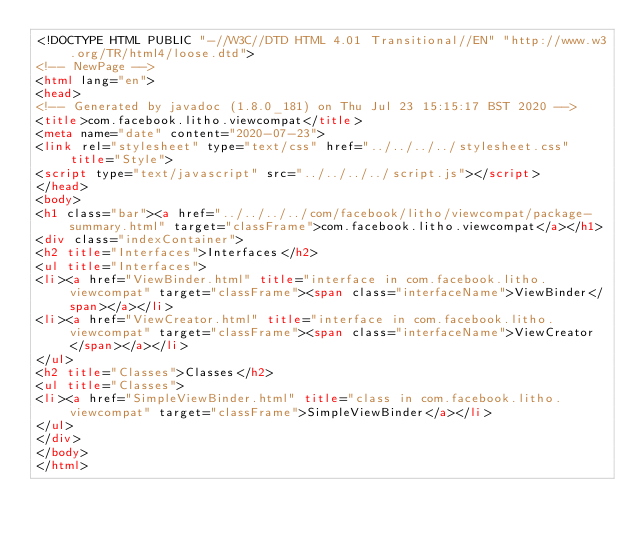<code> <loc_0><loc_0><loc_500><loc_500><_HTML_><!DOCTYPE HTML PUBLIC "-//W3C//DTD HTML 4.01 Transitional//EN" "http://www.w3.org/TR/html4/loose.dtd">
<!-- NewPage -->
<html lang="en">
<head>
<!-- Generated by javadoc (1.8.0_181) on Thu Jul 23 15:15:17 BST 2020 -->
<title>com.facebook.litho.viewcompat</title>
<meta name="date" content="2020-07-23">
<link rel="stylesheet" type="text/css" href="../../../../stylesheet.css" title="Style">
<script type="text/javascript" src="../../../../script.js"></script>
</head>
<body>
<h1 class="bar"><a href="../../../../com/facebook/litho/viewcompat/package-summary.html" target="classFrame">com.facebook.litho.viewcompat</a></h1>
<div class="indexContainer">
<h2 title="Interfaces">Interfaces</h2>
<ul title="Interfaces">
<li><a href="ViewBinder.html" title="interface in com.facebook.litho.viewcompat" target="classFrame"><span class="interfaceName">ViewBinder</span></a></li>
<li><a href="ViewCreator.html" title="interface in com.facebook.litho.viewcompat" target="classFrame"><span class="interfaceName">ViewCreator</span></a></li>
</ul>
<h2 title="Classes">Classes</h2>
<ul title="Classes">
<li><a href="SimpleViewBinder.html" title="class in com.facebook.litho.viewcompat" target="classFrame">SimpleViewBinder</a></li>
</ul>
</div>
</body>
</html>
</code> 